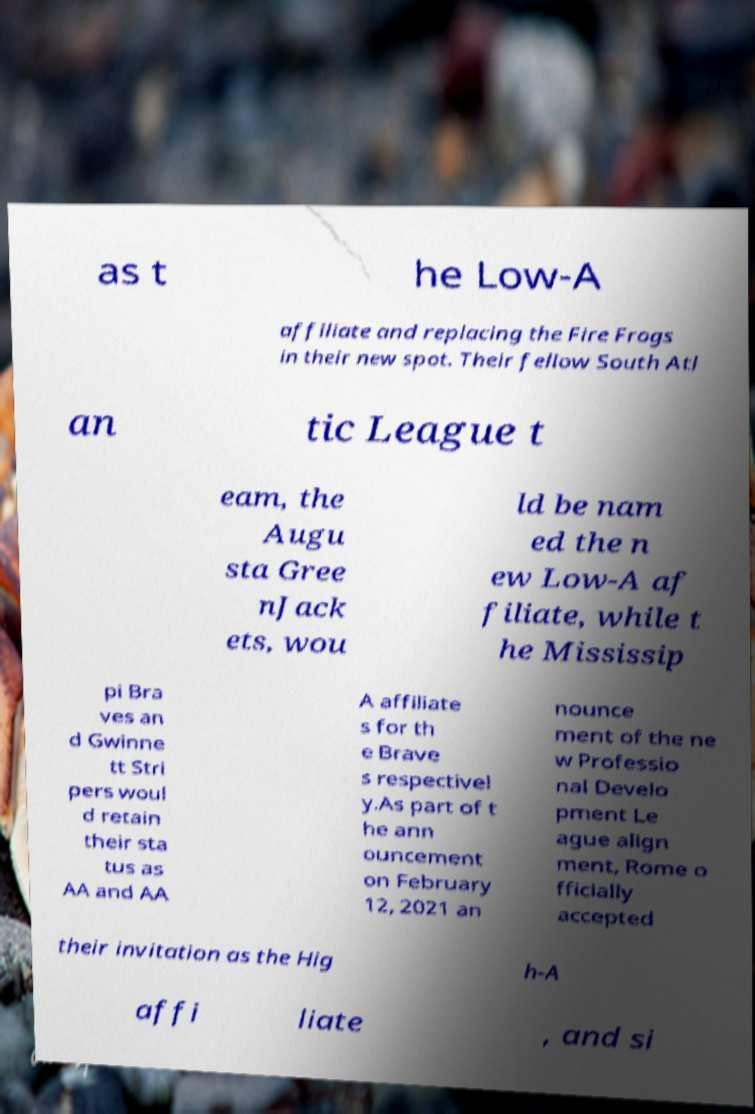Could you extract and type out the text from this image? as t he Low-A affiliate and replacing the Fire Frogs in their new spot. Their fellow South Atl an tic League t eam, the Augu sta Gree nJack ets, wou ld be nam ed the n ew Low-A af filiate, while t he Mississip pi Bra ves an d Gwinne tt Stri pers woul d retain their sta tus as AA and AA A affiliate s for th e Brave s respectivel y.As part of t he ann ouncement on February 12, 2021 an nounce ment of the ne w Professio nal Develo pment Le ague align ment, Rome o fficially accepted their invitation as the Hig h-A affi liate , and si 